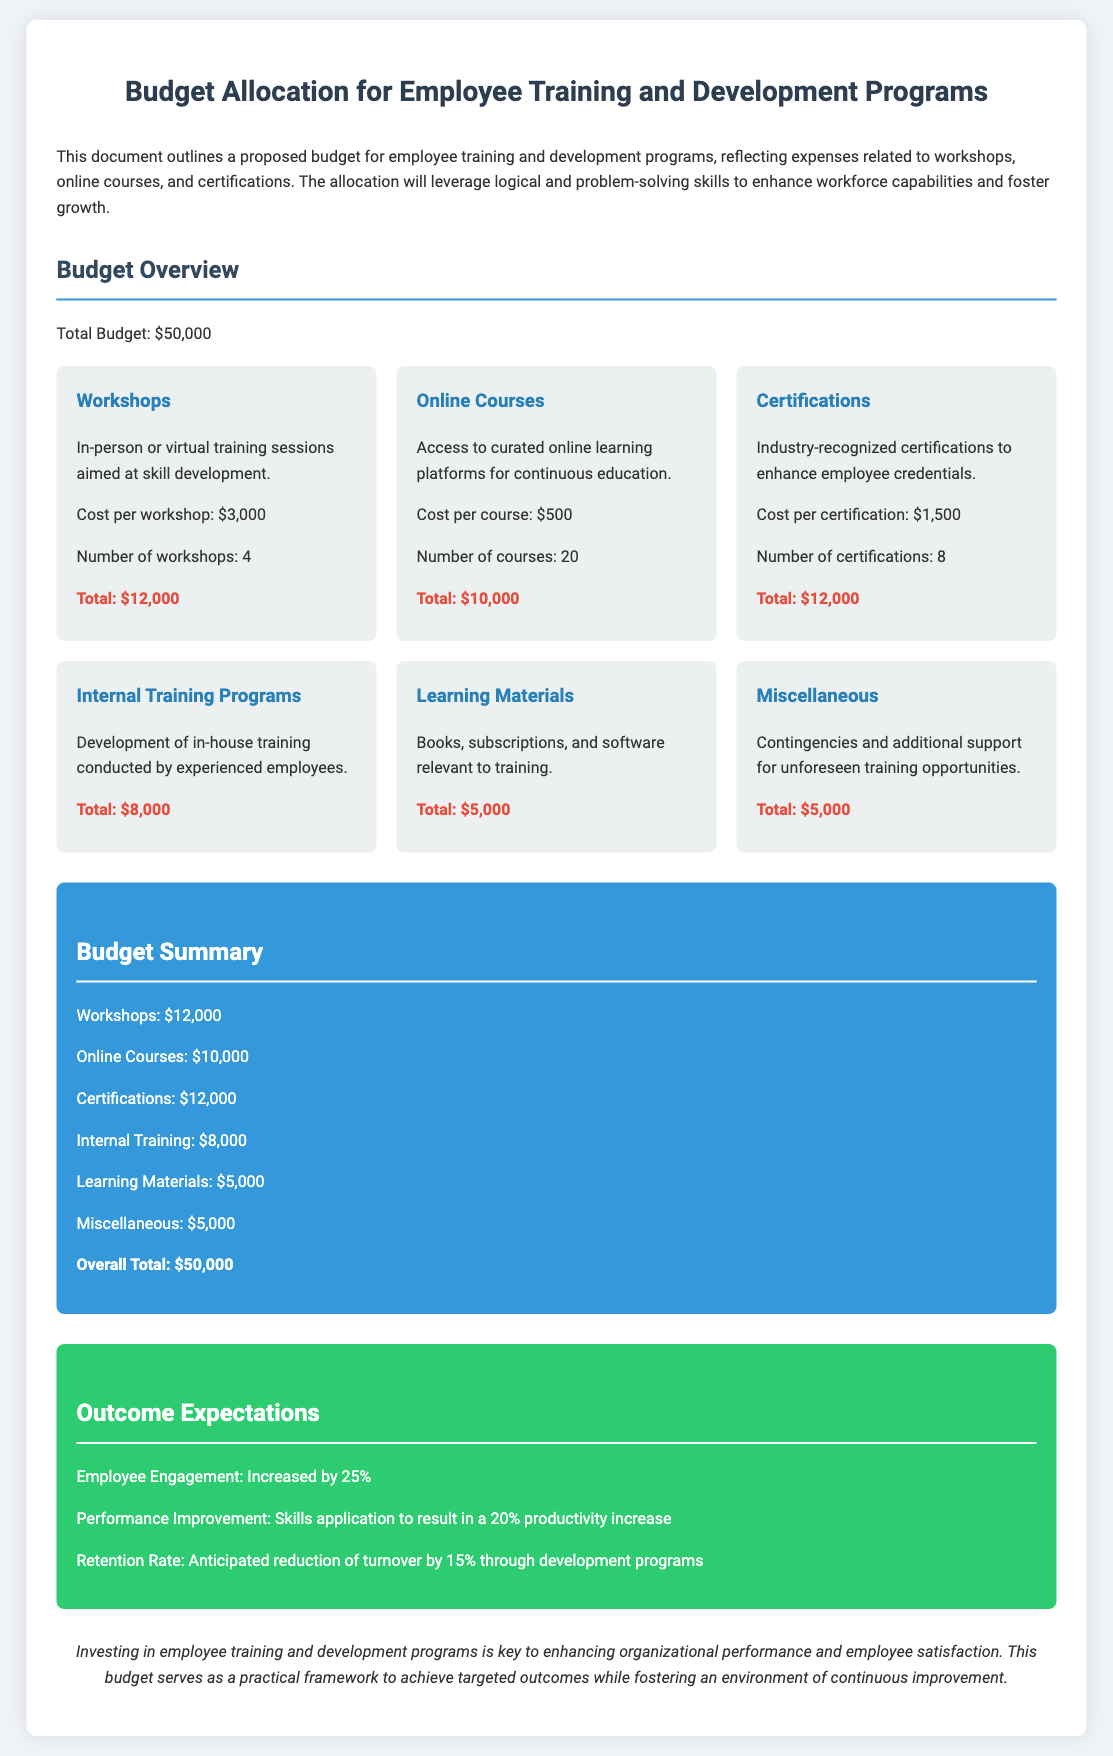What is the total budget? The total budget is stated clearly in the document as a single figure, which is $50,000.
Answer: $50,000 How many workshops are planned? The number of workshops is provided under the workshops section, which states there will be 4 workshops.
Answer: 4 What is the cost per certification? The specific cost per certification can be found in the certifications section, which lists it as $1,500.
Answer: $1,500 What is the total for online courses? The total for online courses is calculated in the summary section, specifying that it amounts to $10,000.
Answer: $10,000 By what percentage is employee engagement expected to increase? This anticipated increase is mentioned in the outcome expectations section, with a clear figure of 25%.
Answer: 25% How much is allocated for learning materials? The budget allocation for learning materials is specified in the learning materials section, indicating a total of $5,000.
Answer: $5,000 What is the expected performance improvement percentage? The performance improvement percentage is stated in the outcome section, indicating a 20% increase.
Answer: 20% What is the total allocated for internal training programs? The total for internal training programs is clearly stated in the internal training section, which is $8,000.
Answer: $8,000 Which category has the highest budget allocation? The budget allocations are summarized, showing that workshops have the highest allocation of $12,000.
Answer: Workshops 